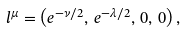<formula> <loc_0><loc_0><loc_500><loc_500>l ^ { \mu } = \left ( e ^ { - \nu / 2 } , \, e ^ { - \lambda / 2 } , \, 0 , \, 0 \right ) ,</formula> 